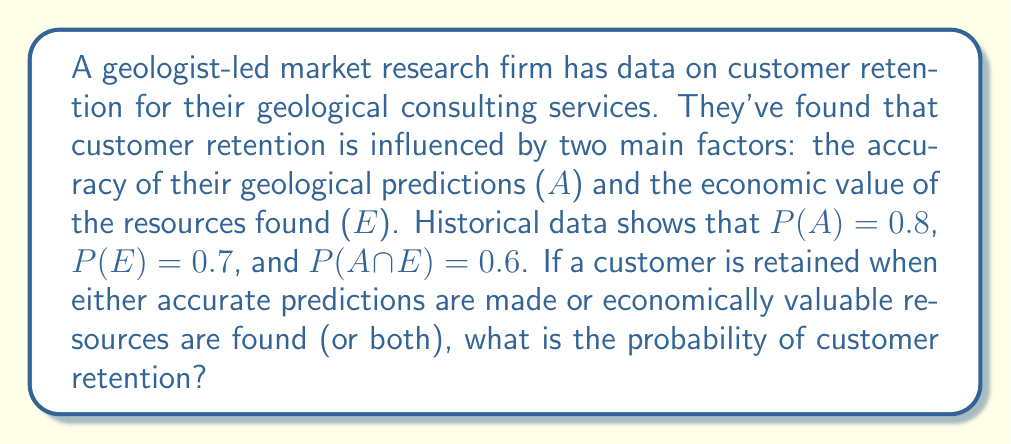What is the answer to this math problem? Let's approach this step-by-step:

1) Let R be the event of customer retention. We need to find P(R).

2) We know that R occurs when A or E (or both) occur. In set theory, this is the union of A and E.

3) We can use the formula for the probability of a union:

   $$P(A \cup E) = P(A) + P(E) - P(A \cap E)$$

4) We are given:
   $$P(A) = 0.8$$
   $$P(E) = 0.7$$
   $$P(A \cap E) = 0.6$$

5) Substituting these values into our formula:

   $$P(R) = P(A \cup E) = 0.8 + 0.7 - 0.6$$

6) Calculating:
   $$P(R) = 0.9$$

Therefore, the probability of customer retention is 0.9 or 90%.
Answer: 0.9 